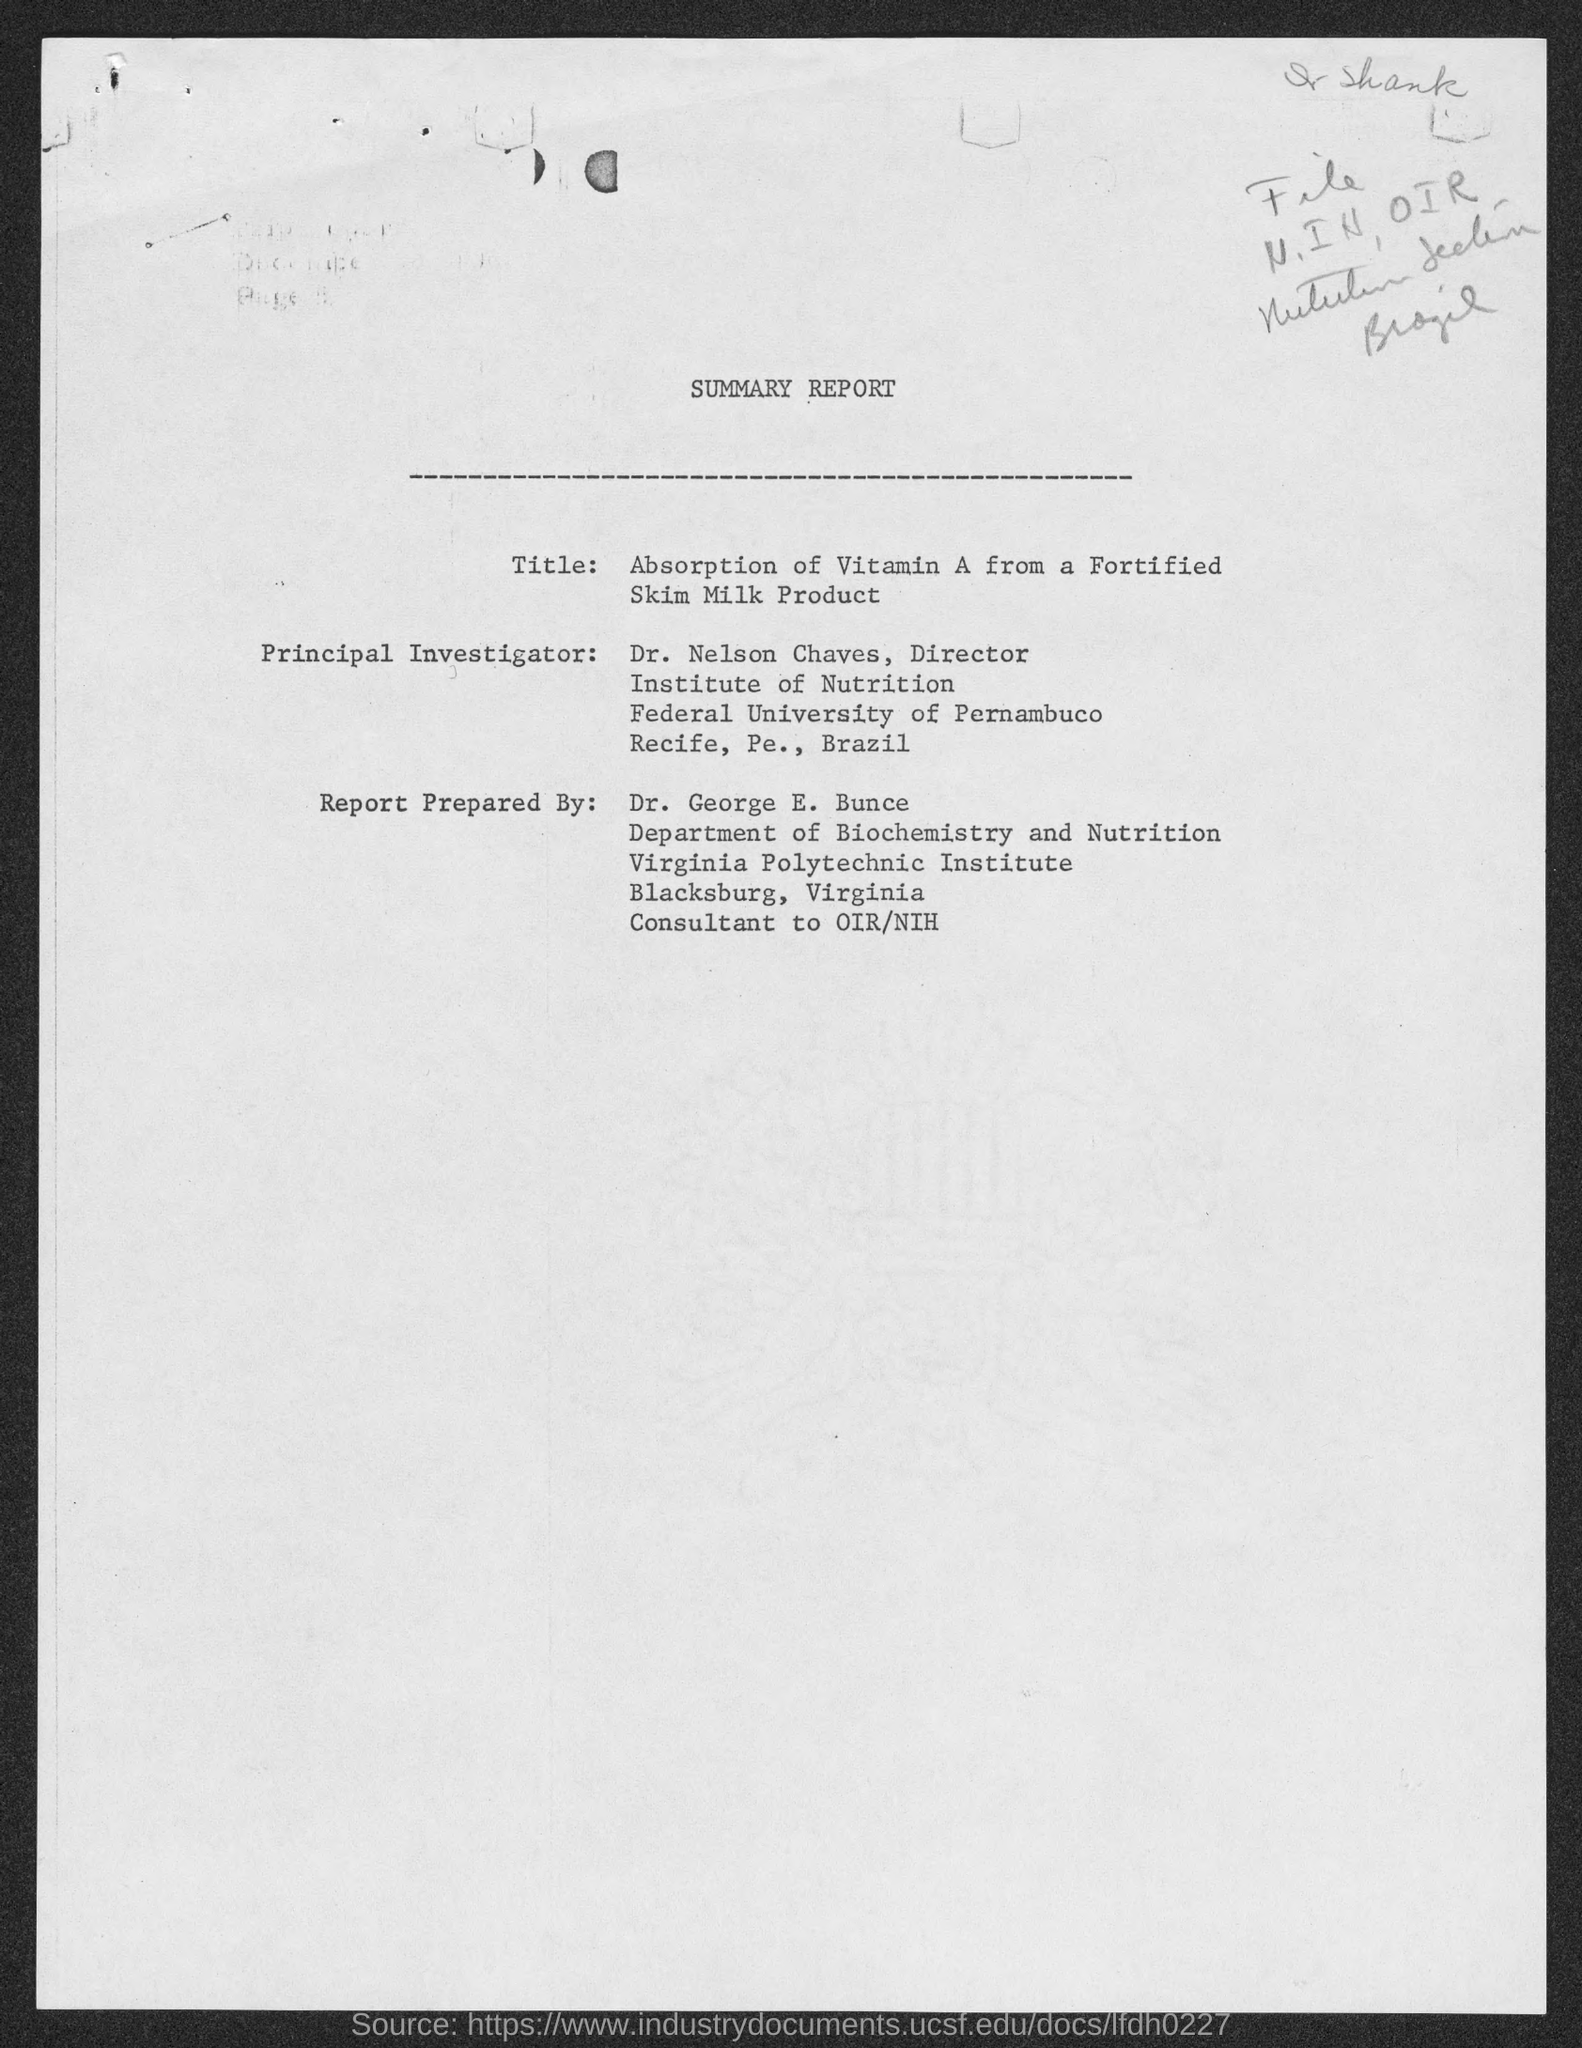Who prepared summary report?
Keep it short and to the point. Dr. George E. Bunce. Who is the principal investigator?
Keep it short and to the point. Dr. nelson chaves. What is the position of dr. nelson chaves ?
Offer a very short reply. Director. To which university does dr. nelson chaves belong ?
Give a very brief answer. Federal university of pernambuco. To which institute does dr. george e.  bunce belong ?
Ensure brevity in your answer.  Virginia polytechnic institute. 